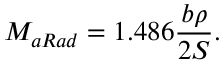Convert formula to latex. <formula><loc_0><loc_0><loc_500><loc_500>M _ { a R a d } = 1 . 4 8 6 \frac { b \rho } { 2 S } .</formula> 